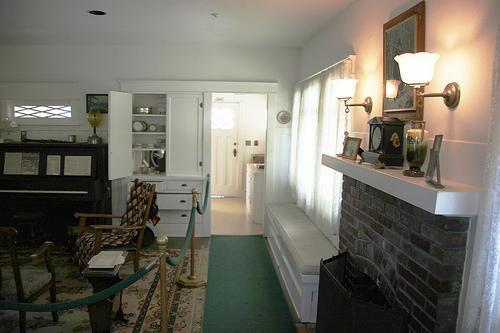How many fireplaces are there?
Give a very brief answer. 1. 